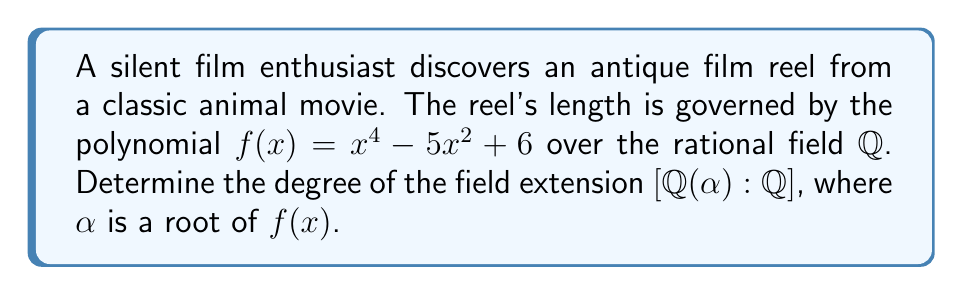Help me with this question. To determine the degree of the field extension, we need to follow these steps:

1) First, we need to factor the polynomial $f(x) = x^4 - 5x^2 + 6$. 
   Let $y = x^2$, then we have $y^2 - 5y + 6 = (y-2)(y-3)$
   So, $f(x) = (x^2-2)(x^2-3)$

2) The roots of $f(x)$ are $\pm\sqrt{2}$ and $\pm\sqrt{3}$

3) Let's choose $\alpha = \sqrt{2}$ (we could choose any of the roots)

4) The minimal polynomial of $\sqrt{2}$ over $\mathbb{Q}$ is $x^2 - 2$

5) The degree of the minimal polynomial is 2

6) By the theorem on the degree of field extensions, we know that:
   $[\mathbb{Q}(\alpha):\mathbb{Q}] = \text{degree of minimal polynomial of }\alpha\text{ over }\mathbb{Q}$

Therefore, $[\mathbb{Q}(\sqrt{2}):\mathbb{Q}] = 2$
Answer: $2$ 